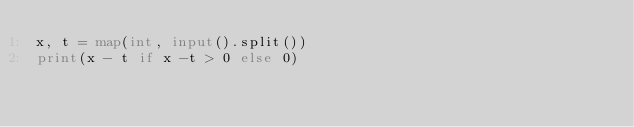<code> <loc_0><loc_0><loc_500><loc_500><_Python_>x, t = map(int, input().split())
print(x - t if x -t > 0 else 0)</code> 